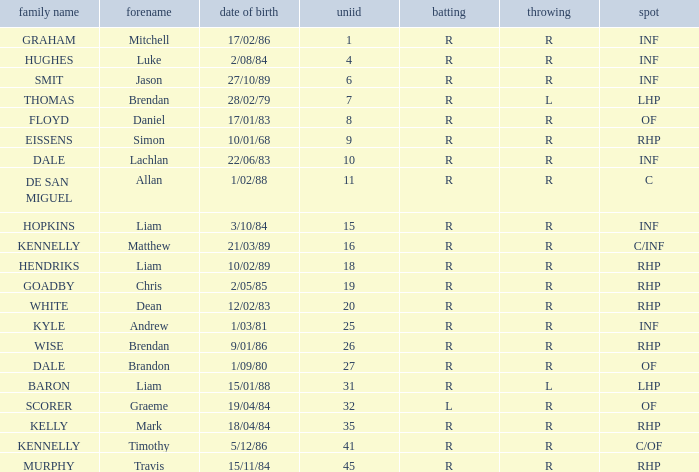Which player has a last name of baron? R. 